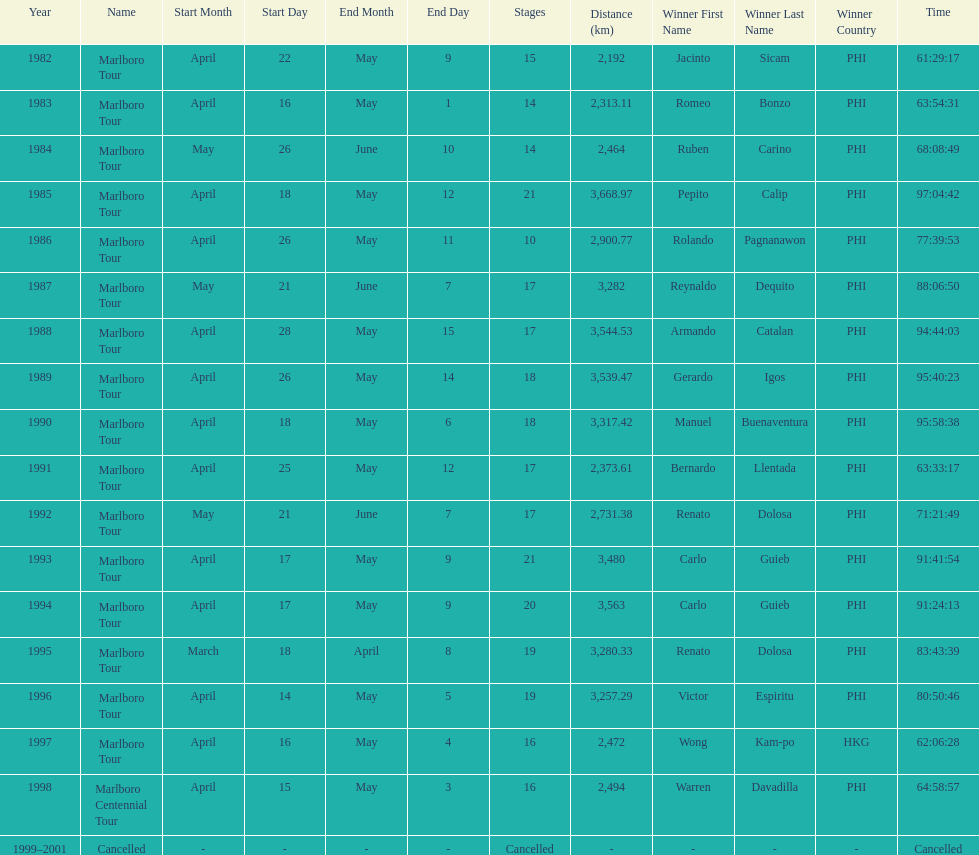Who won the most marlboro tours? Carlo Guieb. 